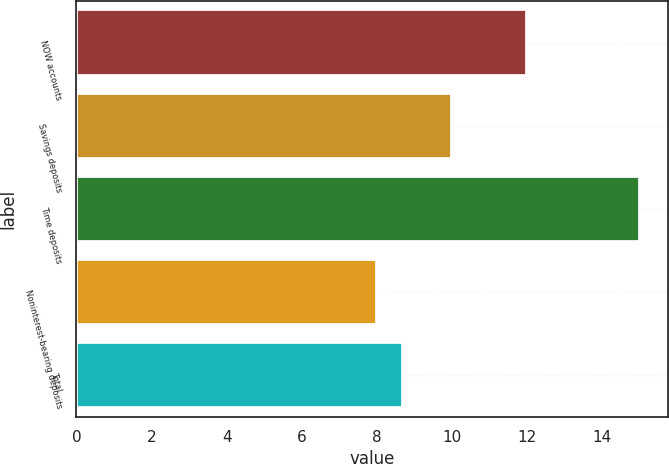Convert chart to OTSL. <chart><loc_0><loc_0><loc_500><loc_500><bar_chart><fcel>NOW accounts<fcel>Savings deposits<fcel>Time deposits<fcel>Noninterest-bearing deposits<fcel>Total<nl><fcel>12<fcel>10<fcel>15<fcel>8<fcel>8.7<nl></chart> 